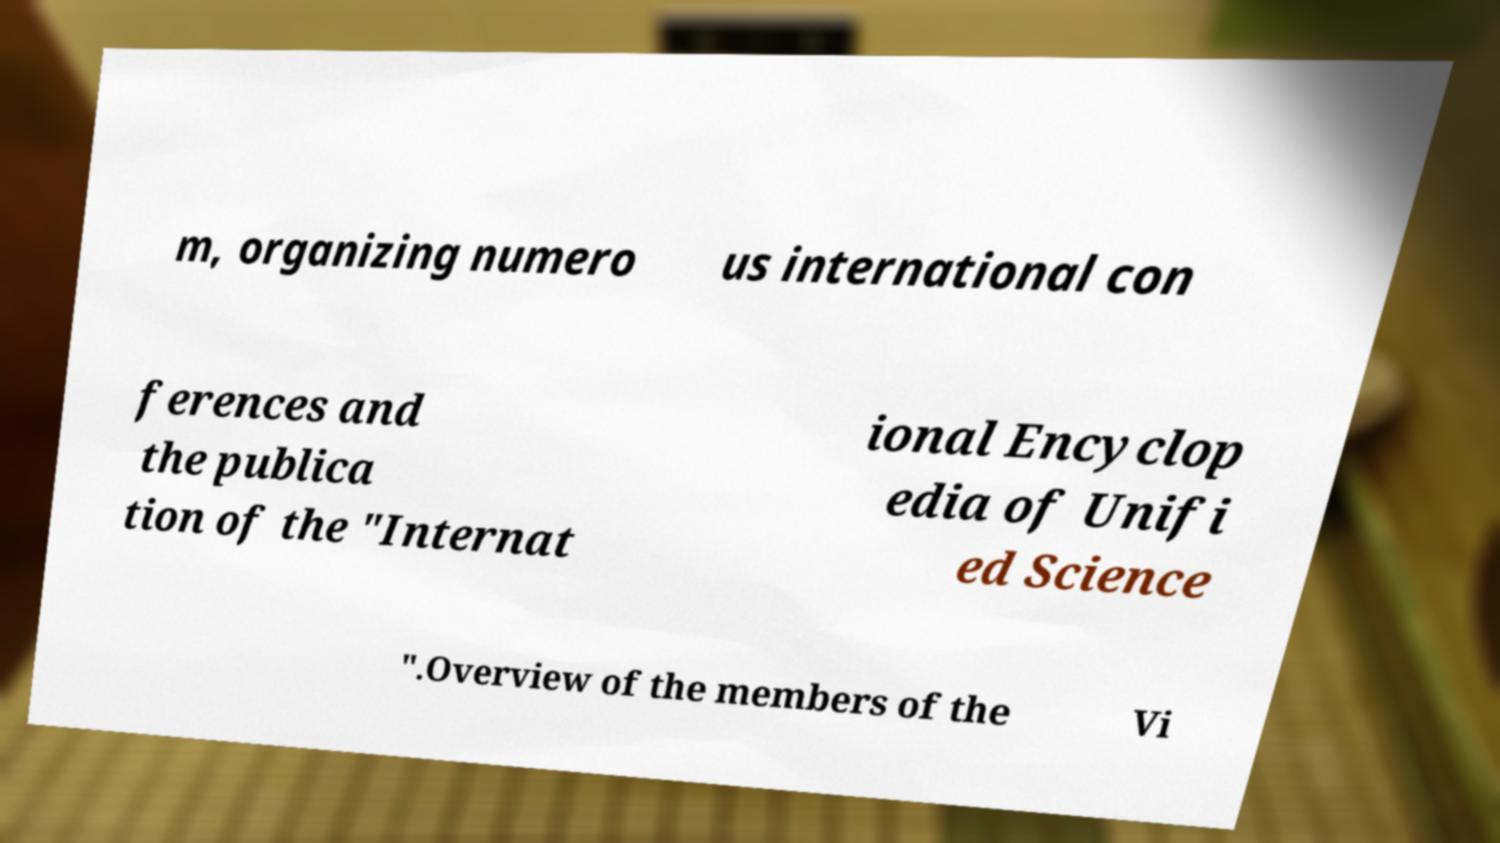What messages or text are displayed in this image? I need them in a readable, typed format. m, organizing numero us international con ferences and the publica tion of the "Internat ional Encyclop edia of Unifi ed Science ".Overview of the members of the Vi 